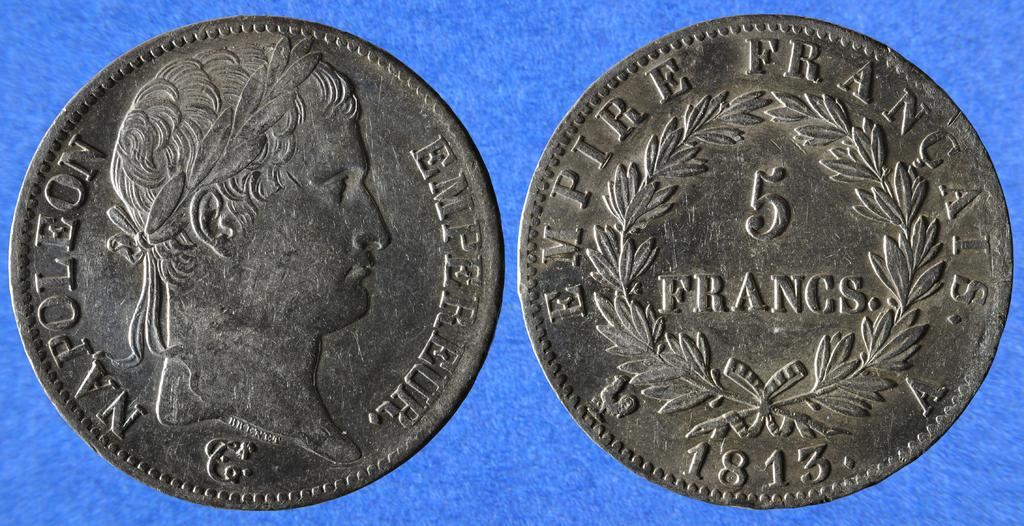<image>
Present a compact description of the photo's key features. Two coins next to one another with one saying Napoleon. 